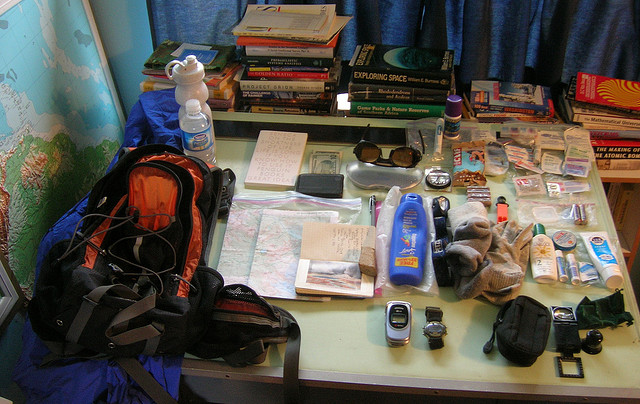What personal care items can be identified in this image? In the image, there are various personal care items laid out, such as a bottle of sunscreen, a toothbrush, toothpaste, and what looks like a bottle of body lotion or mosquito repellent. 